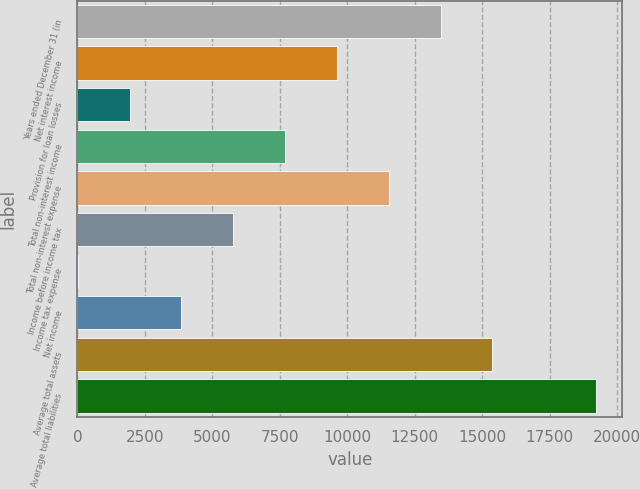<chart> <loc_0><loc_0><loc_500><loc_500><bar_chart><fcel>Years ended December 31 (in<fcel>Net interest income<fcel>Provision for loan losses<fcel>Total non-interest income<fcel>Total non-interest expense<fcel>Income before income tax<fcel>Income tax expense<fcel>Net income<fcel>Average total assets<fcel>Average total liabilities<nl><fcel>13456<fcel>9614.95<fcel>1932.83<fcel>7694.42<fcel>11535.5<fcel>5773.89<fcel>12.3<fcel>3853.36<fcel>15376.5<fcel>19217.6<nl></chart> 